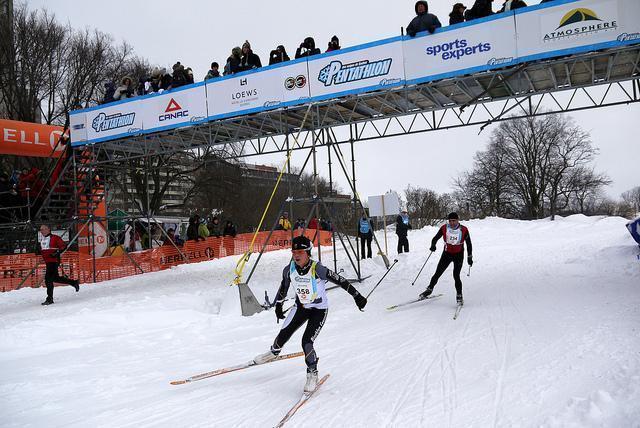What type of signs are shown?
Select the accurate answer and provide justification: `Answer: choice
Rationale: srationale.`
Options: Regulatory, directional, warning, brand. Answer: brand.
Rationale: The signs show brands. 